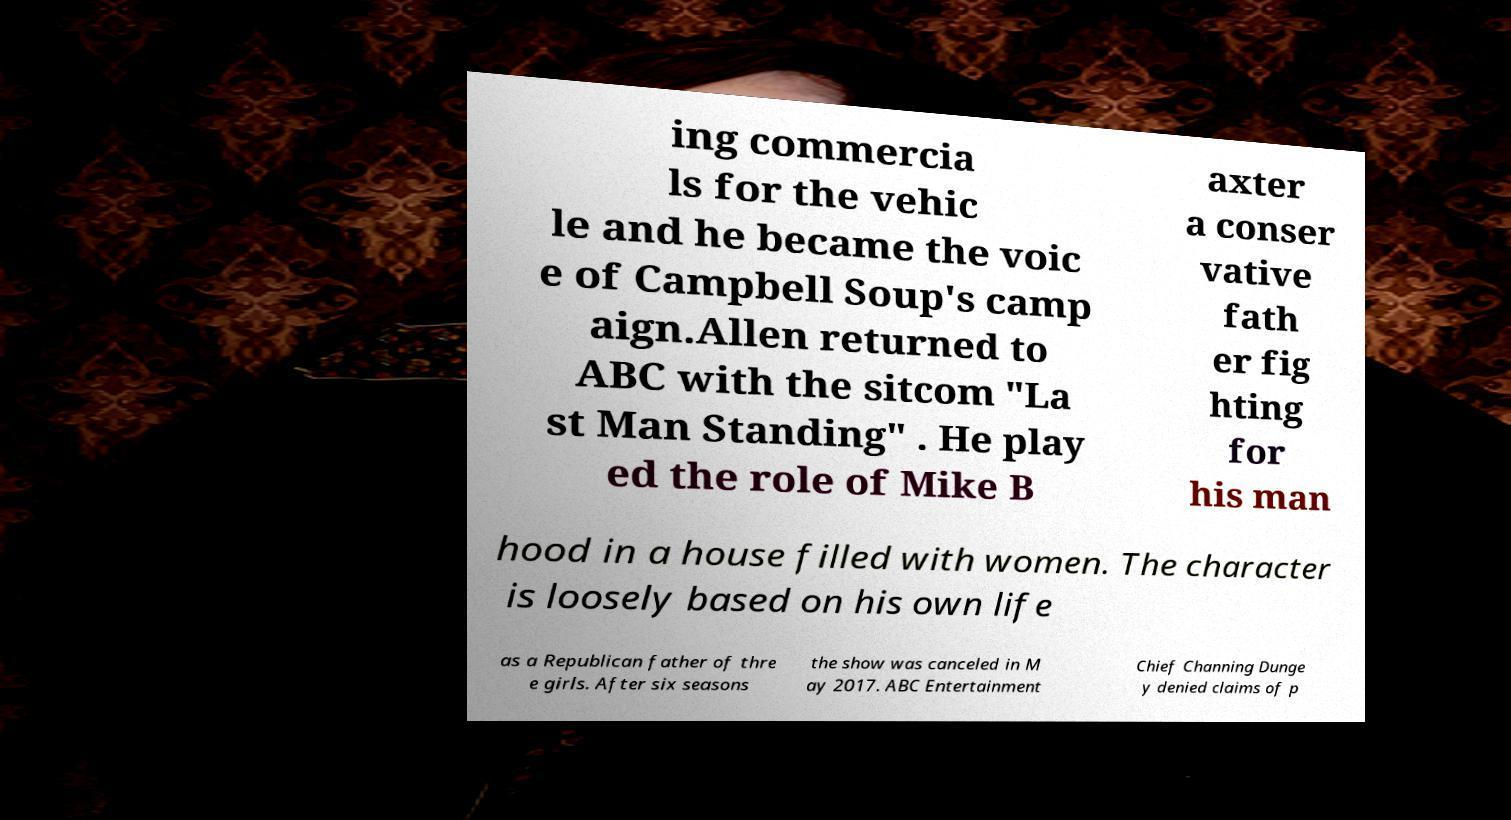What messages or text are displayed in this image? I need them in a readable, typed format. ing commercia ls for the vehic le and he became the voic e of Campbell Soup's camp aign.Allen returned to ABC with the sitcom "La st Man Standing" . He play ed the role of Mike B axter a conser vative fath er fig hting for his man hood in a house filled with women. The character is loosely based on his own life as a Republican father of thre e girls. After six seasons the show was canceled in M ay 2017. ABC Entertainment Chief Channing Dunge y denied claims of p 